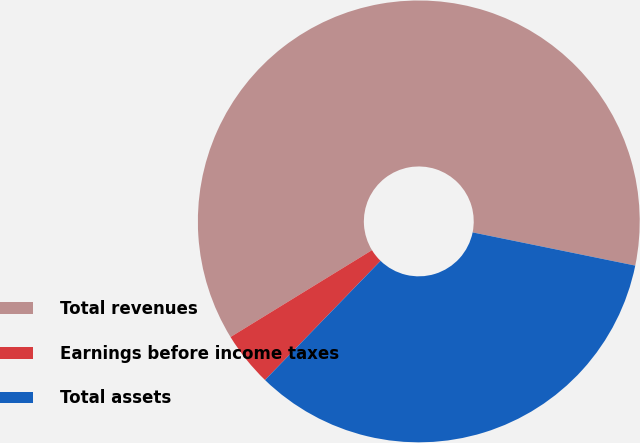<chart> <loc_0><loc_0><loc_500><loc_500><pie_chart><fcel>Total revenues<fcel>Earnings before income taxes<fcel>Total assets<nl><fcel>61.97%<fcel>3.98%<fcel>34.05%<nl></chart> 